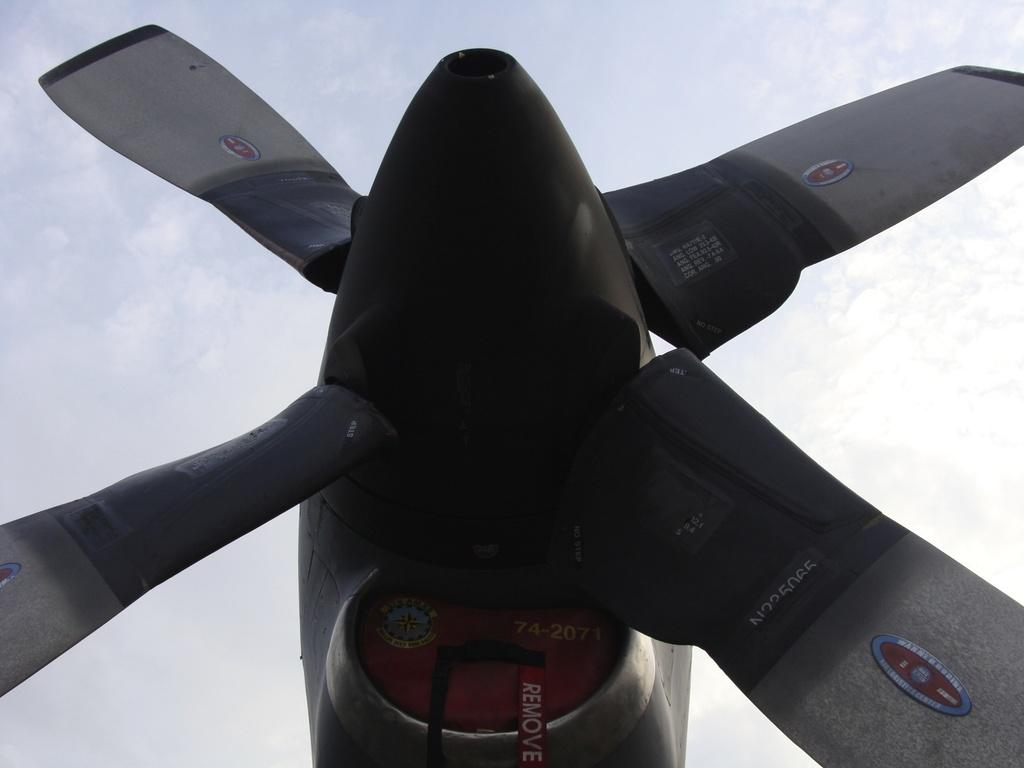What is the main subject of the picture? The main subject of the picture is an airplane propeller. What can be seen in the background of the picture? The sky is visible in the background of the picture. What type of voice can be heard coming from the airplane propeller in the image? There is no voice present in the image, as it features an airplane propeller and the sky. 